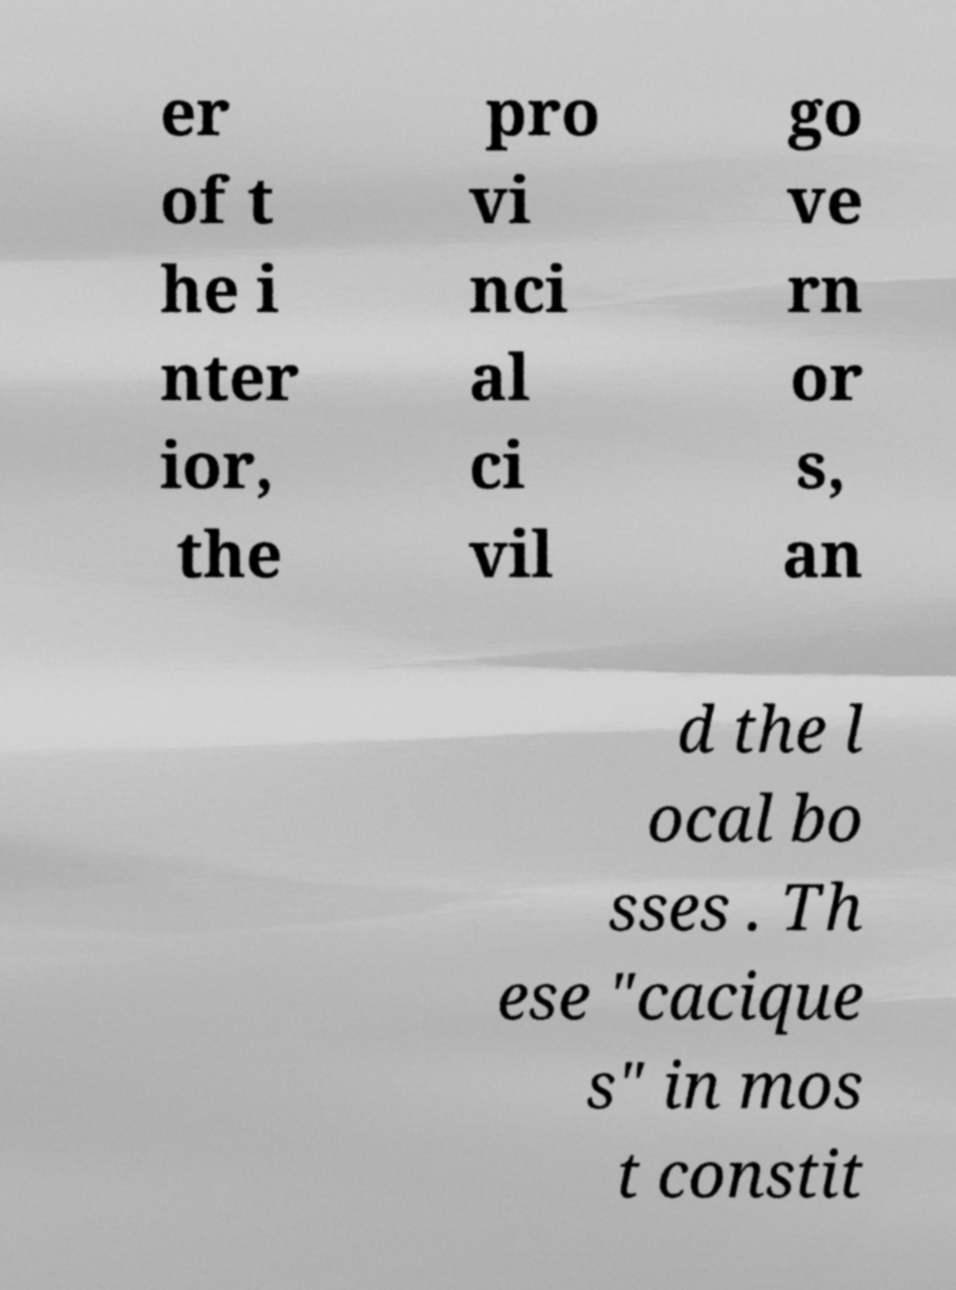Can you accurately transcribe the text from the provided image for me? er of t he i nter ior, the pro vi nci al ci vil go ve rn or s, an d the l ocal bo sses . Th ese "cacique s" in mos t constit 